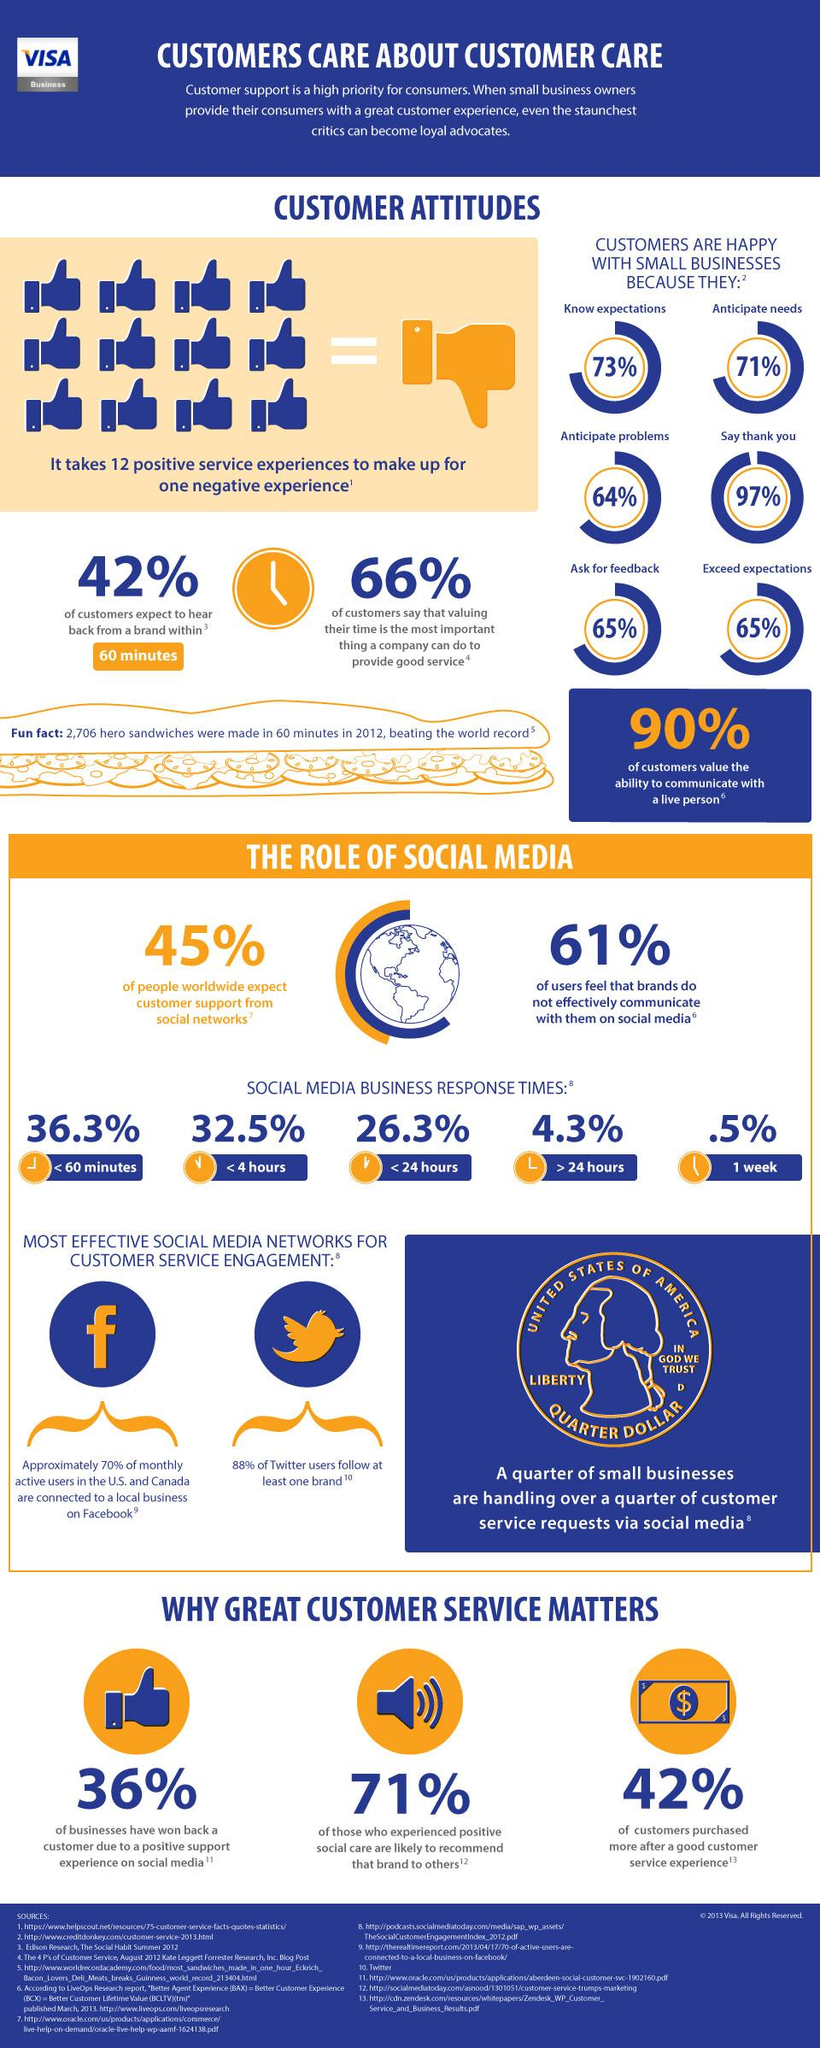Identify some key points in this picture. According to a recent survey, only 39% of people believe that brands effectively communicate with them on social media. According to a recent survey, only 0.5% of social media businesses respond to customer inquiries within 7 days, indicating a significant lack of responsiveness on the part of these companies. The quarter dollar coin is the denomination that is shown in the infographic. According to a survey, 58% of customers do not expect to hear back from a brand within 60 minutes. The infographic displays 13 thumbs up symbols. 